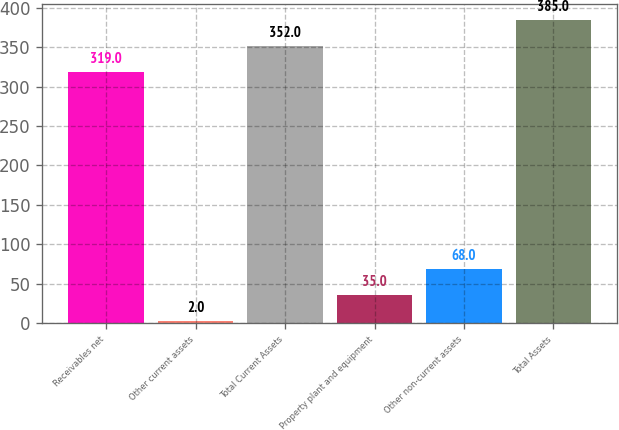Convert chart to OTSL. <chart><loc_0><loc_0><loc_500><loc_500><bar_chart><fcel>Receivables net<fcel>Other current assets<fcel>Total Current Assets<fcel>Property plant and equipment<fcel>Other non-current assets<fcel>Total Assets<nl><fcel>319<fcel>2<fcel>352<fcel>35<fcel>68<fcel>385<nl></chart> 